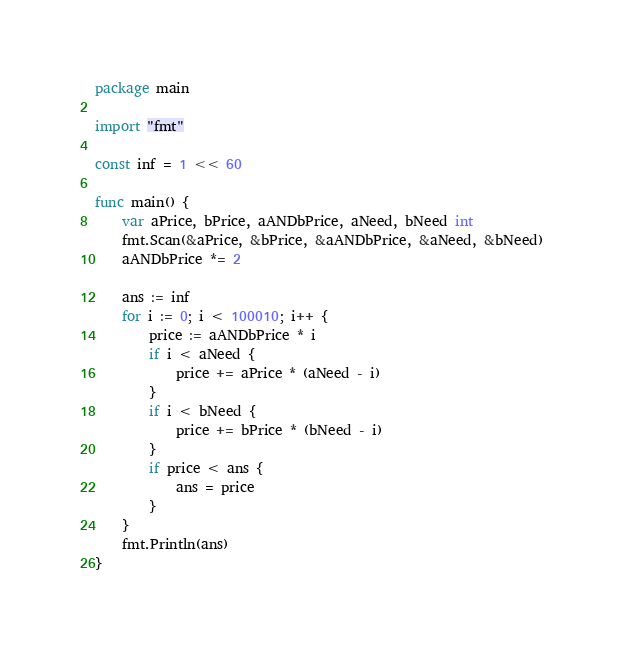Convert code to text. <code><loc_0><loc_0><loc_500><loc_500><_Go_>package main

import "fmt"

const inf = 1 << 60

func main() {
	var aPrice, bPrice, aANDbPrice, aNeed, bNeed int
	fmt.Scan(&aPrice, &bPrice, &aANDbPrice, &aNeed, &bNeed)
	aANDbPrice *= 2

	ans := inf
	for i := 0; i < 100010; i++ {
		price := aANDbPrice * i
		if i < aNeed {
			price += aPrice * (aNeed - i)
		}
		if i < bNeed {
			price += bPrice * (bNeed - i)
		}
		if price < ans {
			ans = price
		}
	}
	fmt.Println(ans)
}
</code> 